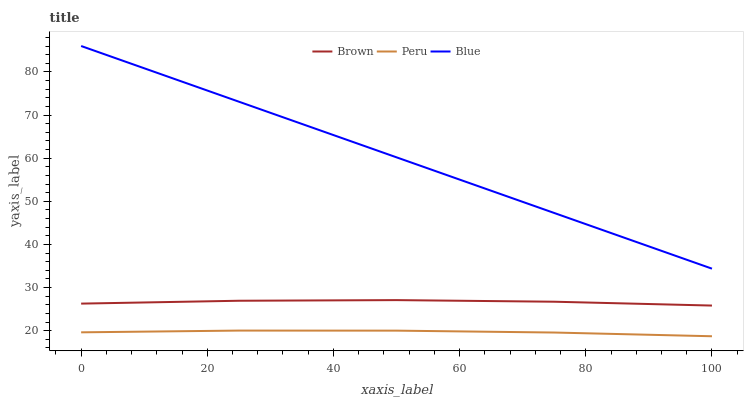Does Peru have the minimum area under the curve?
Answer yes or no. Yes. Does Blue have the maximum area under the curve?
Answer yes or no. Yes. Does Brown have the minimum area under the curve?
Answer yes or no. No. Does Brown have the maximum area under the curve?
Answer yes or no. No. Is Blue the smoothest?
Answer yes or no. Yes. Is Brown the roughest?
Answer yes or no. Yes. Is Peru the smoothest?
Answer yes or no. No. Is Peru the roughest?
Answer yes or no. No. Does Peru have the lowest value?
Answer yes or no. Yes. Does Brown have the lowest value?
Answer yes or no. No. Does Blue have the highest value?
Answer yes or no. Yes. Does Brown have the highest value?
Answer yes or no. No. Is Peru less than Blue?
Answer yes or no. Yes. Is Blue greater than Peru?
Answer yes or no. Yes. Does Peru intersect Blue?
Answer yes or no. No. 